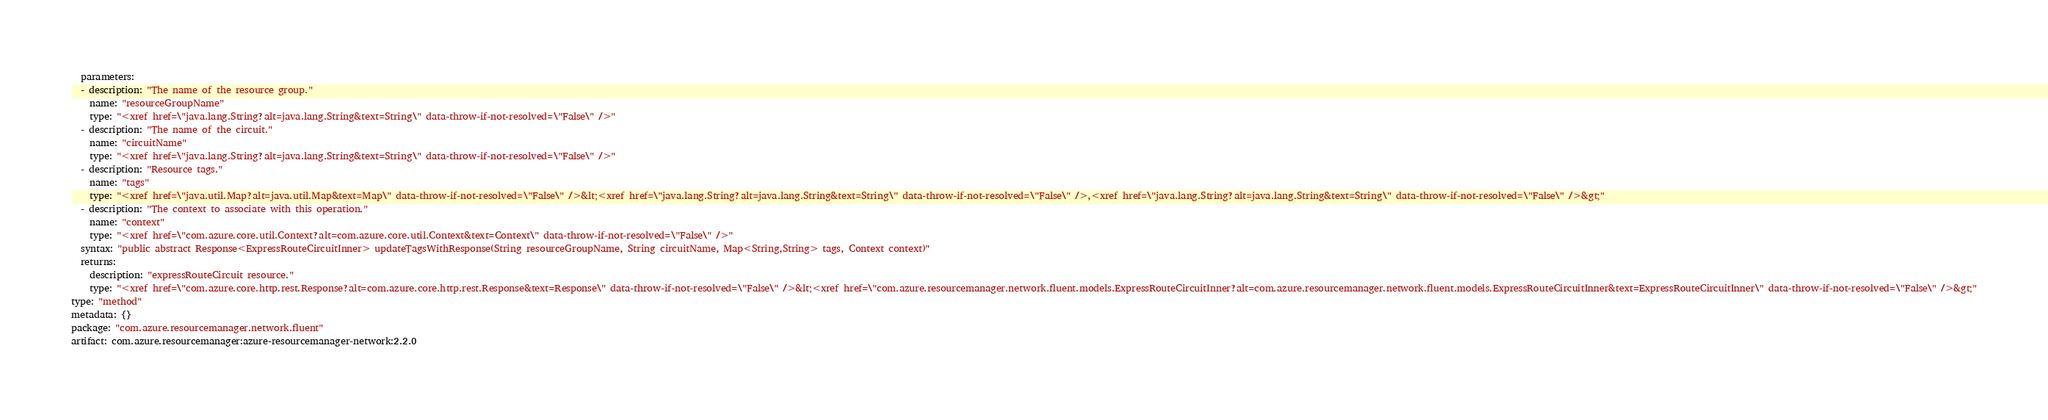Convert code to text. <code><loc_0><loc_0><loc_500><loc_500><_YAML_>  parameters:
  - description: "The name of the resource group."
    name: "resourceGroupName"
    type: "<xref href=\"java.lang.String?alt=java.lang.String&text=String\" data-throw-if-not-resolved=\"False\" />"
  - description: "The name of the circuit."
    name: "circuitName"
    type: "<xref href=\"java.lang.String?alt=java.lang.String&text=String\" data-throw-if-not-resolved=\"False\" />"
  - description: "Resource tags."
    name: "tags"
    type: "<xref href=\"java.util.Map?alt=java.util.Map&text=Map\" data-throw-if-not-resolved=\"False\" />&lt;<xref href=\"java.lang.String?alt=java.lang.String&text=String\" data-throw-if-not-resolved=\"False\" />,<xref href=\"java.lang.String?alt=java.lang.String&text=String\" data-throw-if-not-resolved=\"False\" />&gt;"
  - description: "The context to associate with this operation."
    name: "context"
    type: "<xref href=\"com.azure.core.util.Context?alt=com.azure.core.util.Context&text=Context\" data-throw-if-not-resolved=\"False\" />"
  syntax: "public abstract Response<ExpressRouteCircuitInner> updateTagsWithResponse(String resourceGroupName, String circuitName, Map<String,String> tags, Context context)"
  returns:
    description: "expressRouteCircuit resource."
    type: "<xref href=\"com.azure.core.http.rest.Response?alt=com.azure.core.http.rest.Response&text=Response\" data-throw-if-not-resolved=\"False\" />&lt;<xref href=\"com.azure.resourcemanager.network.fluent.models.ExpressRouteCircuitInner?alt=com.azure.resourcemanager.network.fluent.models.ExpressRouteCircuitInner&text=ExpressRouteCircuitInner\" data-throw-if-not-resolved=\"False\" />&gt;"
type: "method"
metadata: {}
package: "com.azure.resourcemanager.network.fluent"
artifact: com.azure.resourcemanager:azure-resourcemanager-network:2.2.0
</code> 